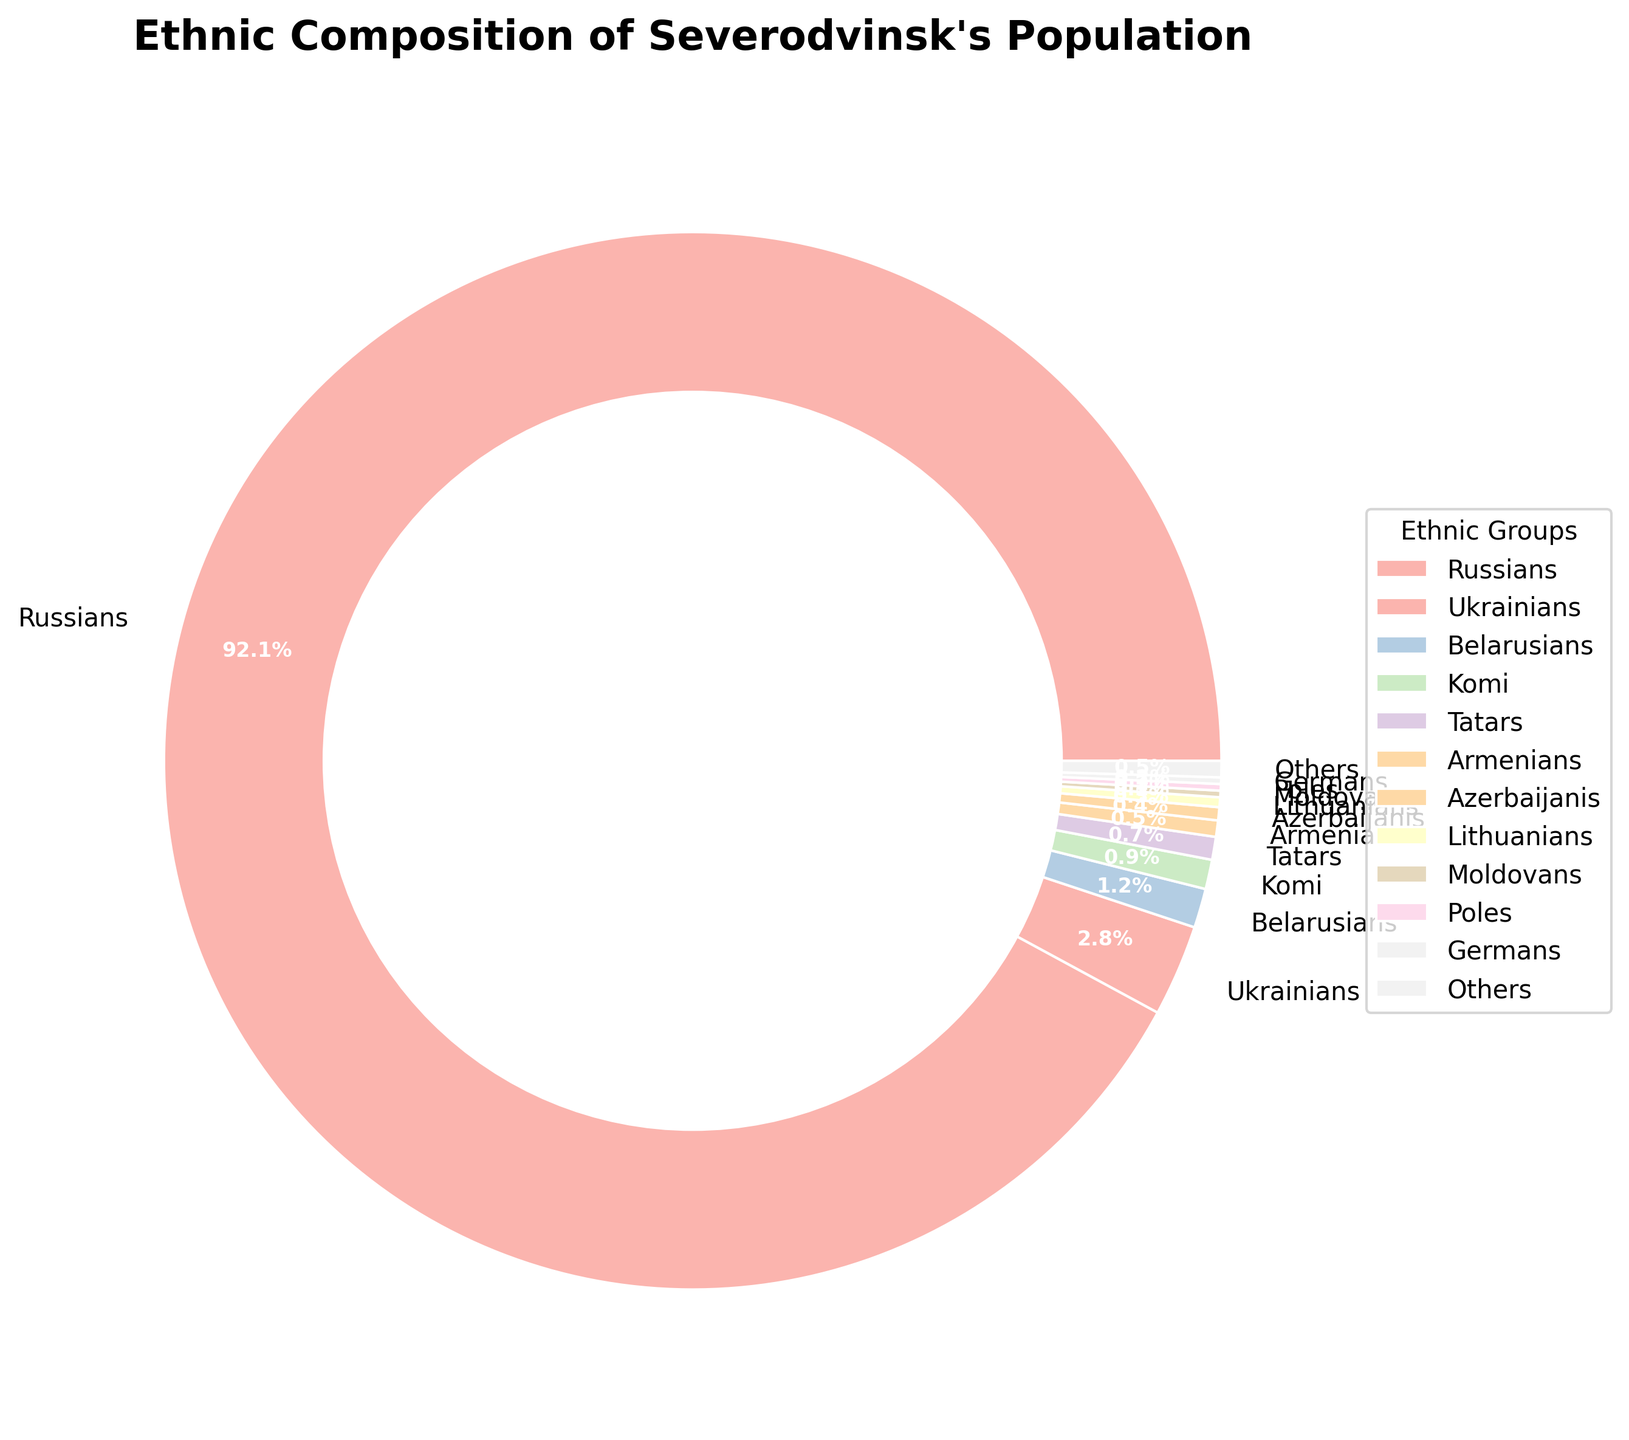Which ethnic group constitutes the largest percentage of the population? To determine the largest group, we look for the biggest slice in the pie chart. The chart shows that Russians make up the largest portion.
Answer: Russians Which ethnic group represents 0.9% of the population? Locate the slice that is labeled with 0.9% and find its corresponding ethnic group. The chart shows that Komi represents 0.9%.
Answer: Komi By how much percentage do Ukrainians exceed Belarusians? Find the percentage of Ukrainians (2.8%) and Belarusians (1.2%), then subtract the percentage of Belarusians from Ukrainians: 2.8% - 1.2% = 1.6%.
Answer: 1.6% What is the combined percentage of Tatars, Armenians, and Azerbaijanis? Add the percentages of Tatars (0.7%), Armenians (0.5%), and Azerbaijanis (0.4%): 0.7% + 0.5% + 0.4% = 1.6%.
Answer: 1.6% Which ethnic group has a smaller percentage than Germans but larger than Moldovans? Compare percentages to find the ethnic groups smaller than Germans (0.2%) but larger than Moldovans (0.2%). Neither exceeds 0.2%, so there isn't one.
Answer: None How many ethnic groups have a population percentage of less than 1%? Count the slices with percentages less than 1%: Ukrainians, Belarusians, Komi, Tatars, Armenians, Azerbaijanis, Lithuanians, Moldovans, Poles, Germans, Others. So there are 11 groups.
Answer: 11 What is the total percentage of ethnic groups labeled as 'Others'? Directly refer to the slice labeled 'Others' which shows 0.5%.
Answer: 0.5% Which ethnic group’s representation in the population is closest to the mean percentage of all ethnic groups listed? Calculate the mean by summing all percentages and dividing by number of groups: (92.1 + 2.8 + 1.2 + 0.9 + 0.7 + 0.5 + 0.4 + 0.3 + 0.2 + 0.2 + 0.2 + 0.5) / 12 = 8.4%. Compare this to each group to see Tatars at 0.7% is closest.
Answer: Tatars 